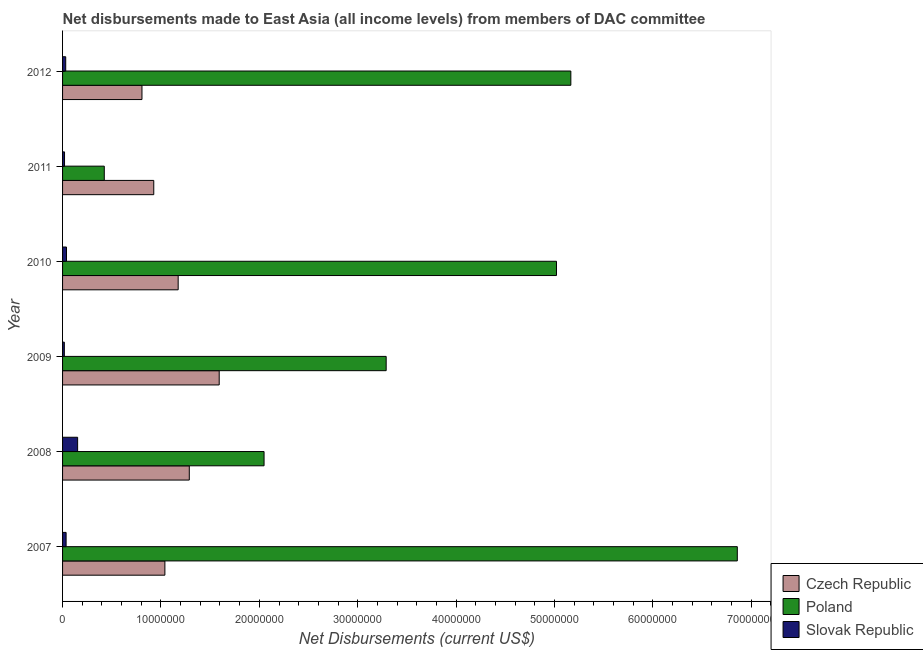How many groups of bars are there?
Your response must be concise. 6. Are the number of bars per tick equal to the number of legend labels?
Provide a succinct answer. Yes. How many bars are there on the 2nd tick from the bottom?
Make the answer very short. 3. What is the label of the 1st group of bars from the top?
Your response must be concise. 2012. What is the net disbursements made by poland in 2009?
Provide a succinct answer. 3.29e+07. Across all years, what is the maximum net disbursements made by slovak republic?
Give a very brief answer. 1.53e+06. Across all years, what is the minimum net disbursements made by slovak republic?
Give a very brief answer. 1.80e+05. In which year was the net disbursements made by poland maximum?
Ensure brevity in your answer.  2007. In which year was the net disbursements made by slovak republic minimum?
Ensure brevity in your answer.  2009. What is the total net disbursements made by czech republic in the graph?
Provide a succinct answer. 6.83e+07. What is the difference between the net disbursements made by slovak republic in 2011 and that in 2012?
Offer a terse response. -1.20e+05. What is the difference between the net disbursements made by poland in 2011 and the net disbursements made by slovak republic in 2008?
Offer a terse response. 2.71e+06. What is the average net disbursements made by poland per year?
Your response must be concise. 3.80e+07. In the year 2008, what is the difference between the net disbursements made by slovak republic and net disbursements made by czech republic?
Make the answer very short. -1.14e+07. What is the ratio of the net disbursements made by poland in 2009 to that in 2010?
Ensure brevity in your answer.  0.66. Is the net disbursements made by slovak republic in 2008 less than that in 2010?
Your answer should be compact. No. Is the difference between the net disbursements made by czech republic in 2008 and 2009 greater than the difference between the net disbursements made by poland in 2008 and 2009?
Ensure brevity in your answer.  Yes. What is the difference between the highest and the second highest net disbursements made by czech republic?
Make the answer very short. 3.04e+06. What is the difference between the highest and the lowest net disbursements made by poland?
Offer a very short reply. 6.43e+07. In how many years, is the net disbursements made by slovak republic greater than the average net disbursements made by slovak republic taken over all years?
Your answer should be compact. 1. What does the 1st bar from the top in 2008 represents?
Give a very brief answer. Slovak Republic. What does the 1st bar from the bottom in 2011 represents?
Keep it short and to the point. Czech Republic. How many bars are there?
Offer a very short reply. 18. How many years are there in the graph?
Provide a succinct answer. 6. Does the graph contain any zero values?
Ensure brevity in your answer.  No. Does the graph contain grids?
Keep it short and to the point. No. Where does the legend appear in the graph?
Your answer should be compact. Bottom right. How are the legend labels stacked?
Your answer should be compact. Vertical. What is the title of the graph?
Your answer should be compact. Net disbursements made to East Asia (all income levels) from members of DAC committee. What is the label or title of the X-axis?
Give a very brief answer. Net Disbursements (current US$). What is the label or title of the Y-axis?
Your response must be concise. Year. What is the Net Disbursements (current US$) in Czech Republic in 2007?
Offer a very short reply. 1.04e+07. What is the Net Disbursements (current US$) of Poland in 2007?
Offer a very short reply. 6.86e+07. What is the Net Disbursements (current US$) in Czech Republic in 2008?
Offer a terse response. 1.29e+07. What is the Net Disbursements (current US$) in Poland in 2008?
Ensure brevity in your answer.  2.05e+07. What is the Net Disbursements (current US$) in Slovak Republic in 2008?
Make the answer very short. 1.53e+06. What is the Net Disbursements (current US$) of Czech Republic in 2009?
Give a very brief answer. 1.59e+07. What is the Net Disbursements (current US$) in Poland in 2009?
Offer a terse response. 3.29e+07. What is the Net Disbursements (current US$) of Slovak Republic in 2009?
Offer a very short reply. 1.80e+05. What is the Net Disbursements (current US$) of Czech Republic in 2010?
Give a very brief answer. 1.18e+07. What is the Net Disbursements (current US$) in Poland in 2010?
Provide a succinct answer. 5.02e+07. What is the Net Disbursements (current US$) of Slovak Republic in 2010?
Offer a very short reply. 4.00e+05. What is the Net Disbursements (current US$) in Czech Republic in 2011?
Your response must be concise. 9.27e+06. What is the Net Disbursements (current US$) in Poland in 2011?
Provide a succinct answer. 4.24e+06. What is the Net Disbursements (current US$) of Slovak Republic in 2011?
Keep it short and to the point. 2.00e+05. What is the Net Disbursements (current US$) of Czech Republic in 2012?
Offer a very short reply. 8.07e+06. What is the Net Disbursements (current US$) of Poland in 2012?
Your response must be concise. 5.17e+07. Across all years, what is the maximum Net Disbursements (current US$) of Czech Republic?
Offer a terse response. 1.59e+07. Across all years, what is the maximum Net Disbursements (current US$) in Poland?
Give a very brief answer. 6.86e+07. Across all years, what is the maximum Net Disbursements (current US$) in Slovak Republic?
Provide a succinct answer. 1.53e+06. Across all years, what is the minimum Net Disbursements (current US$) of Czech Republic?
Give a very brief answer. 8.07e+06. Across all years, what is the minimum Net Disbursements (current US$) of Poland?
Make the answer very short. 4.24e+06. What is the total Net Disbursements (current US$) of Czech Republic in the graph?
Make the answer very short. 6.83e+07. What is the total Net Disbursements (current US$) in Poland in the graph?
Keep it short and to the point. 2.28e+08. What is the total Net Disbursements (current US$) of Slovak Republic in the graph?
Give a very brief answer. 2.99e+06. What is the difference between the Net Disbursements (current US$) in Czech Republic in 2007 and that in 2008?
Your answer should be very brief. -2.48e+06. What is the difference between the Net Disbursements (current US$) in Poland in 2007 and that in 2008?
Your answer should be very brief. 4.81e+07. What is the difference between the Net Disbursements (current US$) of Slovak Republic in 2007 and that in 2008?
Keep it short and to the point. -1.17e+06. What is the difference between the Net Disbursements (current US$) of Czech Republic in 2007 and that in 2009?
Your answer should be very brief. -5.52e+06. What is the difference between the Net Disbursements (current US$) in Poland in 2007 and that in 2009?
Your response must be concise. 3.57e+07. What is the difference between the Net Disbursements (current US$) in Slovak Republic in 2007 and that in 2009?
Ensure brevity in your answer.  1.80e+05. What is the difference between the Net Disbursements (current US$) in Czech Republic in 2007 and that in 2010?
Provide a succinct answer. -1.35e+06. What is the difference between the Net Disbursements (current US$) in Poland in 2007 and that in 2010?
Give a very brief answer. 1.84e+07. What is the difference between the Net Disbursements (current US$) of Slovak Republic in 2007 and that in 2010?
Keep it short and to the point. -4.00e+04. What is the difference between the Net Disbursements (current US$) of Czech Republic in 2007 and that in 2011?
Your answer should be compact. 1.13e+06. What is the difference between the Net Disbursements (current US$) in Poland in 2007 and that in 2011?
Provide a short and direct response. 6.43e+07. What is the difference between the Net Disbursements (current US$) of Czech Republic in 2007 and that in 2012?
Offer a very short reply. 2.33e+06. What is the difference between the Net Disbursements (current US$) of Poland in 2007 and that in 2012?
Give a very brief answer. 1.69e+07. What is the difference between the Net Disbursements (current US$) in Slovak Republic in 2007 and that in 2012?
Offer a very short reply. 4.00e+04. What is the difference between the Net Disbursements (current US$) of Czech Republic in 2008 and that in 2009?
Make the answer very short. -3.04e+06. What is the difference between the Net Disbursements (current US$) in Poland in 2008 and that in 2009?
Provide a succinct answer. -1.24e+07. What is the difference between the Net Disbursements (current US$) in Slovak Republic in 2008 and that in 2009?
Make the answer very short. 1.35e+06. What is the difference between the Net Disbursements (current US$) in Czech Republic in 2008 and that in 2010?
Provide a succinct answer. 1.13e+06. What is the difference between the Net Disbursements (current US$) in Poland in 2008 and that in 2010?
Offer a terse response. -2.97e+07. What is the difference between the Net Disbursements (current US$) in Slovak Republic in 2008 and that in 2010?
Give a very brief answer. 1.13e+06. What is the difference between the Net Disbursements (current US$) of Czech Republic in 2008 and that in 2011?
Offer a terse response. 3.61e+06. What is the difference between the Net Disbursements (current US$) of Poland in 2008 and that in 2011?
Your answer should be compact. 1.62e+07. What is the difference between the Net Disbursements (current US$) of Slovak Republic in 2008 and that in 2011?
Provide a succinct answer. 1.33e+06. What is the difference between the Net Disbursements (current US$) of Czech Republic in 2008 and that in 2012?
Your response must be concise. 4.81e+06. What is the difference between the Net Disbursements (current US$) in Poland in 2008 and that in 2012?
Provide a succinct answer. -3.12e+07. What is the difference between the Net Disbursements (current US$) of Slovak Republic in 2008 and that in 2012?
Your response must be concise. 1.21e+06. What is the difference between the Net Disbursements (current US$) of Czech Republic in 2009 and that in 2010?
Your answer should be very brief. 4.17e+06. What is the difference between the Net Disbursements (current US$) in Poland in 2009 and that in 2010?
Keep it short and to the point. -1.73e+07. What is the difference between the Net Disbursements (current US$) in Slovak Republic in 2009 and that in 2010?
Offer a terse response. -2.20e+05. What is the difference between the Net Disbursements (current US$) in Czech Republic in 2009 and that in 2011?
Your answer should be very brief. 6.65e+06. What is the difference between the Net Disbursements (current US$) of Poland in 2009 and that in 2011?
Offer a very short reply. 2.86e+07. What is the difference between the Net Disbursements (current US$) in Slovak Republic in 2009 and that in 2011?
Give a very brief answer. -2.00e+04. What is the difference between the Net Disbursements (current US$) of Czech Republic in 2009 and that in 2012?
Provide a short and direct response. 7.85e+06. What is the difference between the Net Disbursements (current US$) in Poland in 2009 and that in 2012?
Provide a short and direct response. -1.88e+07. What is the difference between the Net Disbursements (current US$) of Slovak Republic in 2009 and that in 2012?
Keep it short and to the point. -1.40e+05. What is the difference between the Net Disbursements (current US$) of Czech Republic in 2010 and that in 2011?
Make the answer very short. 2.48e+06. What is the difference between the Net Disbursements (current US$) of Poland in 2010 and that in 2011?
Provide a succinct answer. 4.60e+07. What is the difference between the Net Disbursements (current US$) of Czech Republic in 2010 and that in 2012?
Provide a short and direct response. 3.68e+06. What is the difference between the Net Disbursements (current US$) in Poland in 2010 and that in 2012?
Make the answer very short. -1.46e+06. What is the difference between the Net Disbursements (current US$) of Slovak Republic in 2010 and that in 2012?
Offer a terse response. 8.00e+04. What is the difference between the Net Disbursements (current US$) of Czech Republic in 2011 and that in 2012?
Give a very brief answer. 1.20e+06. What is the difference between the Net Disbursements (current US$) of Poland in 2011 and that in 2012?
Ensure brevity in your answer.  -4.74e+07. What is the difference between the Net Disbursements (current US$) of Slovak Republic in 2011 and that in 2012?
Offer a terse response. -1.20e+05. What is the difference between the Net Disbursements (current US$) of Czech Republic in 2007 and the Net Disbursements (current US$) of Poland in 2008?
Provide a short and direct response. -1.01e+07. What is the difference between the Net Disbursements (current US$) in Czech Republic in 2007 and the Net Disbursements (current US$) in Slovak Republic in 2008?
Offer a terse response. 8.87e+06. What is the difference between the Net Disbursements (current US$) in Poland in 2007 and the Net Disbursements (current US$) in Slovak Republic in 2008?
Offer a very short reply. 6.70e+07. What is the difference between the Net Disbursements (current US$) of Czech Republic in 2007 and the Net Disbursements (current US$) of Poland in 2009?
Offer a terse response. -2.25e+07. What is the difference between the Net Disbursements (current US$) of Czech Republic in 2007 and the Net Disbursements (current US$) of Slovak Republic in 2009?
Offer a terse response. 1.02e+07. What is the difference between the Net Disbursements (current US$) in Poland in 2007 and the Net Disbursements (current US$) in Slovak Republic in 2009?
Your answer should be compact. 6.84e+07. What is the difference between the Net Disbursements (current US$) in Czech Republic in 2007 and the Net Disbursements (current US$) in Poland in 2010?
Provide a succinct answer. -3.98e+07. What is the difference between the Net Disbursements (current US$) in Czech Republic in 2007 and the Net Disbursements (current US$) in Slovak Republic in 2010?
Provide a succinct answer. 1.00e+07. What is the difference between the Net Disbursements (current US$) of Poland in 2007 and the Net Disbursements (current US$) of Slovak Republic in 2010?
Keep it short and to the point. 6.82e+07. What is the difference between the Net Disbursements (current US$) of Czech Republic in 2007 and the Net Disbursements (current US$) of Poland in 2011?
Offer a very short reply. 6.16e+06. What is the difference between the Net Disbursements (current US$) in Czech Republic in 2007 and the Net Disbursements (current US$) in Slovak Republic in 2011?
Keep it short and to the point. 1.02e+07. What is the difference between the Net Disbursements (current US$) of Poland in 2007 and the Net Disbursements (current US$) of Slovak Republic in 2011?
Your answer should be compact. 6.84e+07. What is the difference between the Net Disbursements (current US$) in Czech Republic in 2007 and the Net Disbursements (current US$) in Poland in 2012?
Make the answer very short. -4.13e+07. What is the difference between the Net Disbursements (current US$) of Czech Republic in 2007 and the Net Disbursements (current US$) of Slovak Republic in 2012?
Your answer should be very brief. 1.01e+07. What is the difference between the Net Disbursements (current US$) in Poland in 2007 and the Net Disbursements (current US$) in Slovak Republic in 2012?
Provide a short and direct response. 6.83e+07. What is the difference between the Net Disbursements (current US$) of Czech Republic in 2008 and the Net Disbursements (current US$) of Poland in 2009?
Your response must be concise. -2.00e+07. What is the difference between the Net Disbursements (current US$) in Czech Republic in 2008 and the Net Disbursements (current US$) in Slovak Republic in 2009?
Your answer should be very brief. 1.27e+07. What is the difference between the Net Disbursements (current US$) of Poland in 2008 and the Net Disbursements (current US$) of Slovak Republic in 2009?
Make the answer very short. 2.03e+07. What is the difference between the Net Disbursements (current US$) of Czech Republic in 2008 and the Net Disbursements (current US$) of Poland in 2010?
Your answer should be very brief. -3.73e+07. What is the difference between the Net Disbursements (current US$) of Czech Republic in 2008 and the Net Disbursements (current US$) of Slovak Republic in 2010?
Your answer should be very brief. 1.25e+07. What is the difference between the Net Disbursements (current US$) in Poland in 2008 and the Net Disbursements (current US$) in Slovak Republic in 2010?
Make the answer very short. 2.01e+07. What is the difference between the Net Disbursements (current US$) in Czech Republic in 2008 and the Net Disbursements (current US$) in Poland in 2011?
Offer a very short reply. 8.64e+06. What is the difference between the Net Disbursements (current US$) in Czech Republic in 2008 and the Net Disbursements (current US$) in Slovak Republic in 2011?
Your answer should be very brief. 1.27e+07. What is the difference between the Net Disbursements (current US$) of Poland in 2008 and the Net Disbursements (current US$) of Slovak Republic in 2011?
Offer a very short reply. 2.03e+07. What is the difference between the Net Disbursements (current US$) in Czech Republic in 2008 and the Net Disbursements (current US$) in Poland in 2012?
Keep it short and to the point. -3.88e+07. What is the difference between the Net Disbursements (current US$) in Czech Republic in 2008 and the Net Disbursements (current US$) in Slovak Republic in 2012?
Give a very brief answer. 1.26e+07. What is the difference between the Net Disbursements (current US$) in Poland in 2008 and the Net Disbursements (current US$) in Slovak Republic in 2012?
Your answer should be compact. 2.02e+07. What is the difference between the Net Disbursements (current US$) in Czech Republic in 2009 and the Net Disbursements (current US$) in Poland in 2010?
Make the answer very short. -3.43e+07. What is the difference between the Net Disbursements (current US$) in Czech Republic in 2009 and the Net Disbursements (current US$) in Slovak Republic in 2010?
Offer a terse response. 1.55e+07. What is the difference between the Net Disbursements (current US$) in Poland in 2009 and the Net Disbursements (current US$) in Slovak Republic in 2010?
Offer a very short reply. 3.25e+07. What is the difference between the Net Disbursements (current US$) in Czech Republic in 2009 and the Net Disbursements (current US$) in Poland in 2011?
Make the answer very short. 1.17e+07. What is the difference between the Net Disbursements (current US$) in Czech Republic in 2009 and the Net Disbursements (current US$) in Slovak Republic in 2011?
Give a very brief answer. 1.57e+07. What is the difference between the Net Disbursements (current US$) of Poland in 2009 and the Net Disbursements (current US$) of Slovak Republic in 2011?
Offer a terse response. 3.27e+07. What is the difference between the Net Disbursements (current US$) of Czech Republic in 2009 and the Net Disbursements (current US$) of Poland in 2012?
Offer a very short reply. -3.57e+07. What is the difference between the Net Disbursements (current US$) in Czech Republic in 2009 and the Net Disbursements (current US$) in Slovak Republic in 2012?
Your response must be concise. 1.56e+07. What is the difference between the Net Disbursements (current US$) of Poland in 2009 and the Net Disbursements (current US$) of Slovak Republic in 2012?
Your answer should be very brief. 3.26e+07. What is the difference between the Net Disbursements (current US$) of Czech Republic in 2010 and the Net Disbursements (current US$) of Poland in 2011?
Your answer should be compact. 7.51e+06. What is the difference between the Net Disbursements (current US$) of Czech Republic in 2010 and the Net Disbursements (current US$) of Slovak Republic in 2011?
Provide a short and direct response. 1.16e+07. What is the difference between the Net Disbursements (current US$) of Czech Republic in 2010 and the Net Disbursements (current US$) of Poland in 2012?
Give a very brief answer. -3.99e+07. What is the difference between the Net Disbursements (current US$) of Czech Republic in 2010 and the Net Disbursements (current US$) of Slovak Republic in 2012?
Provide a succinct answer. 1.14e+07. What is the difference between the Net Disbursements (current US$) of Poland in 2010 and the Net Disbursements (current US$) of Slovak Republic in 2012?
Your answer should be compact. 4.99e+07. What is the difference between the Net Disbursements (current US$) in Czech Republic in 2011 and the Net Disbursements (current US$) in Poland in 2012?
Offer a terse response. -4.24e+07. What is the difference between the Net Disbursements (current US$) of Czech Republic in 2011 and the Net Disbursements (current US$) of Slovak Republic in 2012?
Offer a terse response. 8.95e+06. What is the difference between the Net Disbursements (current US$) of Poland in 2011 and the Net Disbursements (current US$) of Slovak Republic in 2012?
Your response must be concise. 3.92e+06. What is the average Net Disbursements (current US$) in Czech Republic per year?
Make the answer very short. 1.14e+07. What is the average Net Disbursements (current US$) in Poland per year?
Give a very brief answer. 3.80e+07. What is the average Net Disbursements (current US$) in Slovak Republic per year?
Keep it short and to the point. 4.98e+05. In the year 2007, what is the difference between the Net Disbursements (current US$) in Czech Republic and Net Disbursements (current US$) in Poland?
Make the answer very short. -5.82e+07. In the year 2007, what is the difference between the Net Disbursements (current US$) of Czech Republic and Net Disbursements (current US$) of Slovak Republic?
Your answer should be very brief. 1.00e+07. In the year 2007, what is the difference between the Net Disbursements (current US$) in Poland and Net Disbursements (current US$) in Slovak Republic?
Provide a succinct answer. 6.82e+07. In the year 2008, what is the difference between the Net Disbursements (current US$) in Czech Republic and Net Disbursements (current US$) in Poland?
Provide a succinct answer. -7.60e+06. In the year 2008, what is the difference between the Net Disbursements (current US$) of Czech Republic and Net Disbursements (current US$) of Slovak Republic?
Keep it short and to the point. 1.14e+07. In the year 2008, what is the difference between the Net Disbursements (current US$) of Poland and Net Disbursements (current US$) of Slovak Republic?
Provide a short and direct response. 1.90e+07. In the year 2009, what is the difference between the Net Disbursements (current US$) of Czech Republic and Net Disbursements (current US$) of Poland?
Offer a terse response. -1.70e+07. In the year 2009, what is the difference between the Net Disbursements (current US$) of Czech Republic and Net Disbursements (current US$) of Slovak Republic?
Keep it short and to the point. 1.57e+07. In the year 2009, what is the difference between the Net Disbursements (current US$) in Poland and Net Disbursements (current US$) in Slovak Republic?
Your response must be concise. 3.27e+07. In the year 2010, what is the difference between the Net Disbursements (current US$) in Czech Republic and Net Disbursements (current US$) in Poland?
Your answer should be compact. -3.84e+07. In the year 2010, what is the difference between the Net Disbursements (current US$) in Czech Republic and Net Disbursements (current US$) in Slovak Republic?
Offer a terse response. 1.14e+07. In the year 2010, what is the difference between the Net Disbursements (current US$) in Poland and Net Disbursements (current US$) in Slovak Republic?
Keep it short and to the point. 4.98e+07. In the year 2011, what is the difference between the Net Disbursements (current US$) of Czech Republic and Net Disbursements (current US$) of Poland?
Give a very brief answer. 5.03e+06. In the year 2011, what is the difference between the Net Disbursements (current US$) of Czech Republic and Net Disbursements (current US$) of Slovak Republic?
Provide a short and direct response. 9.07e+06. In the year 2011, what is the difference between the Net Disbursements (current US$) in Poland and Net Disbursements (current US$) in Slovak Republic?
Provide a short and direct response. 4.04e+06. In the year 2012, what is the difference between the Net Disbursements (current US$) in Czech Republic and Net Disbursements (current US$) in Poland?
Your response must be concise. -4.36e+07. In the year 2012, what is the difference between the Net Disbursements (current US$) in Czech Republic and Net Disbursements (current US$) in Slovak Republic?
Offer a terse response. 7.75e+06. In the year 2012, what is the difference between the Net Disbursements (current US$) of Poland and Net Disbursements (current US$) of Slovak Republic?
Make the answer very short. 5.13e+07. What is the ratio of the Net Disbursements (current US$) of Czech Republic in 2007 to that in 2008?
Offer a terse response. 0.81. What is the ratio of the Net Disbursements (current US$) in Poland in 2007 to that in 2008?
Offer a very short reply. 3.35. What is the ratio of the Net Disbursements (current US$) of Slovak Republic in 2007 to that in 2008?
Your response must be concise. 0.24. What is the ratio of the Net Disbursements (current US$) of Czech Republic in 2007 to that in 2009?
Your answer should be compact. 0.65. What is the ratio of the Net Disbursements (current US$) in Poland in 2007 to that in 2009?
Your answer should be very brief. 2.09. What is the ratio of the Net Disbursements (current US$) of Czech Republic in 2007 to that in 2010?
Give a very brief answer. 0.89. What is the ratio of the Net Disbursements (current US$) in Poland in 2007 to that in 2010?
Make the answer very short. 1.37. What is the ratio of the Net Disbursements (current US$) in Czech Republic in 2007 to that in 2011?
Your answer should be very brief. 1.12. What is the ratio of the Net Disbursements (current US$) in Poland in 2007 to that in 2011?
Make the answer very short. 16.17. What is the ratio of the Net Disbursements (current US$) in Czech Republic in 2007 to that in 2012?
Give a very brief answer. 1.29. What is the ratio of the Net Disbursements (current US$) of Poland in 2007 to that in 2012?
Your answer should be very brief. 1.33. What is the ratio of the Net Disbursements (current US$) of Slovak Republic in 2007 to that in 2012?
Provide a succinct answer. 1.12. What is the ratio of the Net Disbursements (current US$) of Czech Republic in 2008 to that in 2009?
Make the answer very short. 0.81. What is the ratio of the Net Disbursements (current US$) in Poland in 2008 to that in 2009?
Your response must be concise. 0.62. What is the ratio of the Net Disbursements (current US$) in Slovak Republic in 2008 to that in 2009?
Offer a very short reply. 8.5. What is the ratio of the Net Disbursements (current US$) in Czech Republic in 2008 to that in 2010?
Make the answer very short. 1.1. What is the ratio of the Net Disbursements (current US$) in Poland in 2008 to that in 2010?
Your answer should be compact. 0.41. What is the ratio of the Net Disbursements (current US$) of Slovak Republic in 2008 to that in 2010?
Your response must be concise. 3.83. What is the ratio of the Net Disbursements (current US$) of Czech Republic in 2008 to that in 2011?
Offer a terse response. 1.39. What is the ratio of the Net Disbursements (current US$) in Poland in 2008 to that in 2011?
Offer a terse response. 4.83. What is the ratio of the Net Disbursements (current US$) of Slovak Republic in 2008 to that in 2011?
Your response must be concise. 7.65. What is the ratio of the Net Disbursements (current US$) in Czech Republic in 2008 to that in 2012?
Ensure brevity in your answer.  1.6. What is the ratio of the Net Disbursements (current US$) in Poland in 2008 to that in 2012?
Your answer should be very brief. 0.4. What is the ratio of the Net Disbursements (current US$) in Slovak Republic in 2008 to that in 2012?
Give a very brief answer. 4.78. What is the ratio of the Net Disbursements (current US$) in Czech Republic in 2009 to that in 2010?
Keep it short and to the point. 1.35. What is the ratio of the Net Disbursements (current US$) in Poland in 2009 to that in 2010?
Give a very brief answer. 0.66. What is the ratio of the Net Disbursements (current US$) in Slovak Republic in 2009 to that in 2010?
Keep it short and to the point. 0.45. What is the ratio of the Net Disbursements (current US$) of Czech Republic in 2009 to that in 2011?
Keep it short and to the point. 1.72. What is the ratio of the Net Disbursements (current US$) of Poland in 2009 to that in 2011?
Provide a succinct answer. 7.76. What is the ratio of the Net Disbursements (current US$) of Slovak Republic in 2009 to that in 2011?
Provide a succinct answer. 0.9. What is the ratio of the Net Disbursements (current US$) of Czech Republic in 2009 to that in 2012?
Keep it short and to the point. 1.97. What is the ratio of the Net Disbursements (current US$) of Poland in 2009 to that in 2012?
Offer a very short reply. 0.64. What is the ratio of the Net Disbursements (current US$) of Slovak Republic in 2009 to that in 2012?
Offer a terse response. 0.56. What is the ratio of the Net Disbursements (current US$) of Czech Republic in 2010 to that in 2011?
Your response must be concise. 1.27. What is the ratio of the Net Disbursements (current US$) of Poland in 2010 to that in 2011?
Make the answer very short. 11.84. What is the ratio of the Net Disbursements (current US$) of Slovak Republic in 2010 to that in 2011?
Provide a short and direct response. 2. What is the ratio of the Net Disbursements (current US$) in Czech Republic in 2010 to that in 2012?
Offer a terse response. 1.46. What is the ratio of the Net Disbursements (current US$) of Poland in 2010 to that in 2012?
Ensure brevity in your answer.  0.97. What is the ratio of the Net Disbursements (current US$) in Czech Republic in 2011 to that in 2012?
Ensure brevity in your answer.  1.15. What is the ratio of the Net Disbursements (current US$) in Poland in 2011 to that in 2012?
Your response must be concise. 0.08. What is the ratio of the Net Disbursements (current US$) of Slovak Republic in 2011 to that in 2012?
Your answer should be compact. 0.62. What is the difference between the highest and the second highest Net Disbursements (current US$) of Czech Republic?
Your answer should be very brief. 3.04e+06. What is the difference between the highest and the second highest Net Disbursements (current US$) in Poland?
Ensure brevity in your answer.  1.69e+07. What is the difference between the highest and the second highest Net Disbursements (current US$) of Slovak Republic?
Offer a terse response. 1.13e+06. What is the difference between the highest and the lowest Net Disbursements (current US$) in Czech Republic?
Your answer should be compact. 7.85e+06. What is the difference between the highest and the lowest Net Disbursements (current US$) of Poland?
Give a very brief answer. 6.43e+07. What is the difference between the highest and the lowest Net Disbursements (current US$) in Slovak Republic?
Your answer should be very brief. 1.35e+06. 